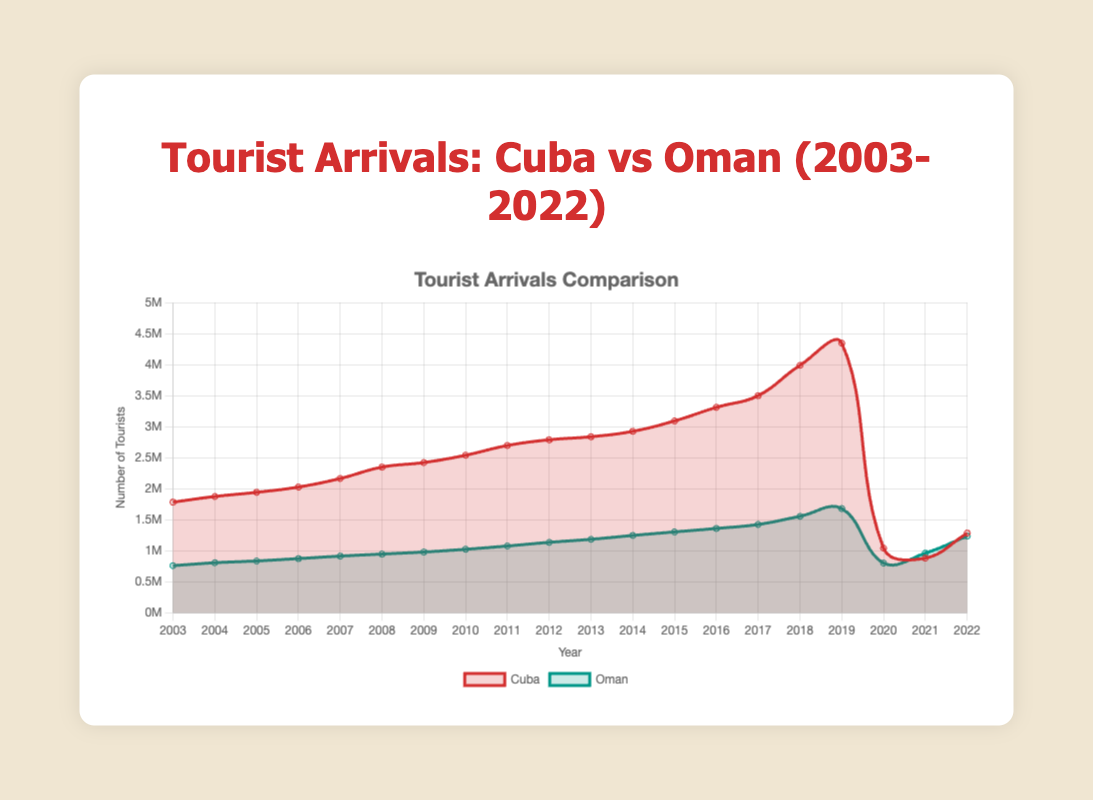How many tourist arrivals were recorded for Cuba in 2015? We look at the data for the year 2015 under Cuba which has 3,091,000 tourist arrivals.
Answer: 3,091,000 Which country had more tourists in 2010? From the chart, Cuba had 2,538,000 tourist arrivals and Oman had 1,022,000 in 2010. Cuba had more tourists.
Answer: Cuba What was the trend in tourist arrivals in Oman from 2007 to 2012? Between 2007 and 2012, the number of tourist arrivals in Oman steadily increased from 912,000 to 1,135,000.
Answer: Steady increase Compare the tourist arrivals between Cuba and Oman in the year 2020. The chart shows that Cuba had 1,040,000 tourists, and Oman had 800,000 tourists in 2020. Cuba had more tourists than Oman in 2020.
Answer: Cuba In which year did Cuba see the highest number of tourist arrivals? The chart shows that Cuba had the highest number of tourist arrivals in 2019 with 4,344,000 tourists.
Answer: 2019 How did the number of tourist arrivals in Oman change from 2017 to 2018? The data indicates that Oman's tourist arrivals increased from 1,422,000 in 2017 to 1,553,000 in 2018.
Answer: Increased What was the difference in tourist arrivals between Cuba and Oman in 2019? In 2019, Cuba had 4,344,000 tourist arrivals, and Oman had 1,679,000. The difference is 4,344,000 - 1,679,000 = 2,665,000.
Answer: 2,665,000 What are the colors representing Cuba and Oman on the chart? From the chart, Cuba is represented by a red color, while Oman is represented by a green color.
Answer: Red for Cuba, Green for Oman Which year saw the lowest number of tourist arrivals in Cuba according to the chart? The chart indicates that 2021 saw the lowest number of tourists in Cuba with 880,000 arrivals.
Answer: 2021 